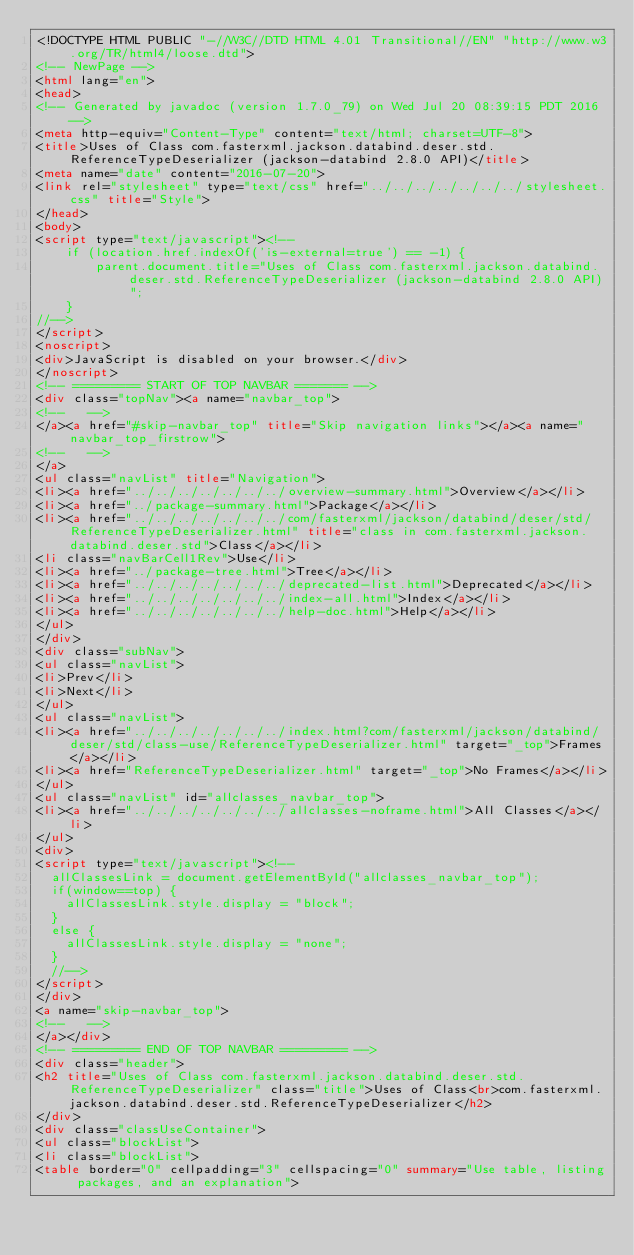Convert code to text. <code><loc_0><loc_0><loc_500><loc_500><_HTML_><!DOCTYPE HTML PUBLIC "-//W3C//DTD HTML 4.01 Transitional//EN" "http://www.w3.org/TR/html4/loose.dtd">
<!-- NewPage -->
<html lang="en">
<head>
<!-- Generated by javadoc (version 1.7.0_79) on Wed Jul 20 08:39:15 PDT 2016 -->
<meta http-equiv="Content-Type" content="text/html; charset=UTF-8">
<title>Uses of Class com.fasterxml.jackson.databind.deser.std.ReferenceTypeDeserializer (jackson-databind 2.8.0 API)</title>
<meta name="date" content="2016-07-20">
<link rel="stylesheet" type="text/css" href="../../../../../../../stylesheet.css" title="Style">
</head>
<body>
<script type="text/javascript"><!--
    if (location.href.indexOf('is-external=true') == -1) {
        parent.document.title="Uses of Class com.fasterxml.jackson.databind.deser.std.ReferenceTypeDeserializer (jackson-databind 2.8.0 API)";
    }
//-->
</script>
<noscript>
<div>JavaScript is disabled on your browser.</div>
</noscript>
<!-- ========= START OF TOP NAVBAR ======= -->
<div class="topNav"><a name="navbar_top">
<!--   -->
</a><a href="#skip-navbar_top" title="Skip navigation links"></a><a name="navbar_top_firstrow">
<!--   -->
</a>
<ul class="navList" title="Navigation">
<li><a href="../../../../../../../overview-summary.html">Overview</a></li>
<li><a href="../package-summary.html">Package</a></li>
<li><a href="../../../../../../../com/fasterxml/jackson/databind/deser/std/ReferenceTypeDeserializer.html" title="class in com.fasterxml.jackson.databind.deser.std">Class</a></li>
<li class="navBarCell1Rev">Use</li>
<li><a href="../package-tree.html">Tree</a></li>
<li><a href="../../../../../../../deprecated-list.html">Deprecated</a></li>
<li><a href="../../../../../../../index-all.html">Index</a></li>
<li><a href="../../../../../../../help-doc.html">Help</a></li>
</ul>
</div>
<div class="subNav">
<ul class="navList">
<li>Prev</li>
<li>Next</li>
</ul>
<ul class="navList">
<li><a href="../../../../../../../index.html?com/fasterxml/jackson/databind/deser/std/class-use/ReferenceTypeDeserializer.html" target="_top">Frames</a></li>
<li><a href="ReferenceTypeDeserializer.html" target="_top">No Frames</a></li>
</ul>
<ul class="navList" id="allclasses_navbar_top">
<li><a href="../../../../../../../allclasses-noframe.html">All Classes</a></li>
</ul>
<div>
<script type="text/javascript"><!--
  allClassesLink = document.getElementById("allclasses_navbar_top");
  if(window==top) {
    allClassesLink.style.display = "block";
  }
  else {
    allClassesLink.style.display = "none";
  }
  //-->
</script>
</div>
<a name="skip-navbar_top">
<!--   -->
</a></div>
<!-- ========= END OF TOP NAVBAR ========= -->
<div class="header">
<h2 title="Uses of Class com.fasterxml.jackson.databind.deser.std.ReferenceTypeDeserializer" class="title">Uses of Class<br>com.fasterxml.jackson.databind.deser.std.ReferenceTypeDeserializer</h2>
</div>
<div class="classUseContainer">
<ul class="blockList">
<li class="blockList">
<table border="0" cellpadding="3" cellspacing="0" summary="Use table, listing packages, and an explanation"></code> 